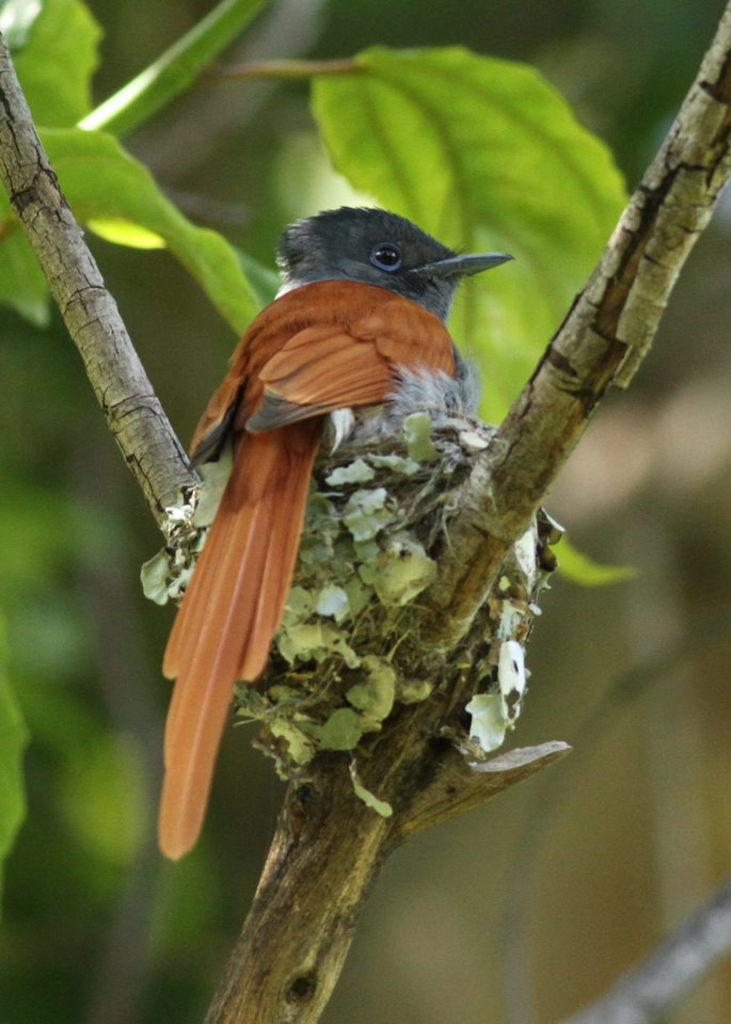In one or two sentences, can you explain what this image depicts? In this image we can see nest on a branch of a tree. Also there is a bird on the nest. In the back there are leaves and it is blurry in the background. 